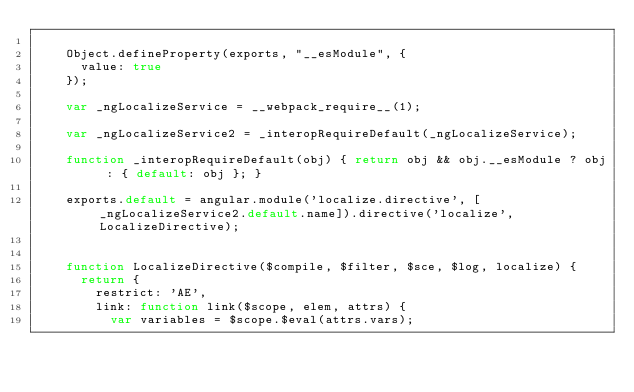Convert code to text. <code><loc_0><loc_0><loc_500><loc_500><_JavaScript_>
	Object.defineProperty(exports, "__esModule", {
	  value: true
	});

	var _ngLocalizeService = __webpack_require__(1);

	var _ngLocalizeService2 = _interopRequireDefault(_ngLocalizeService);

	function _interopRequireDefault(obj) { return obj && obj.__esModule ? obj : { default: obj }; }

	exports.default = angular.module('localize.directive', [_ngLocalizeService2.default.name]).directive('localize', LocalizeDirective);


	function LocalizeDirective($compile, $filter, $sce, $log, localize) {
	  return {
	    restrict: 'AE',
	    link: function link($scope, elem, attrs) {
	      var variables = $scope.$eval(attrs.vars);</code> 